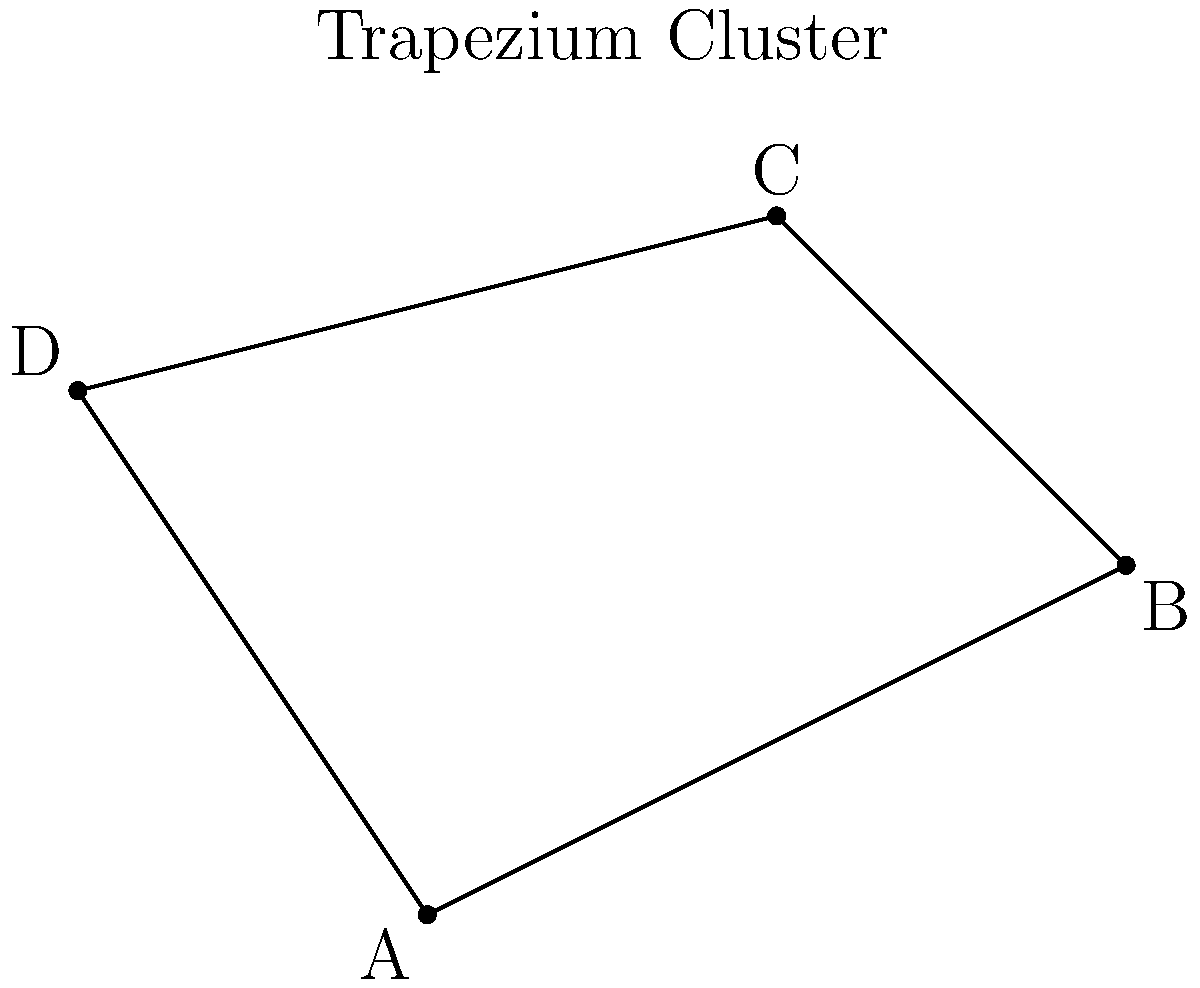During your astrophotography session in Lille, you capture an image of the Orion Nebula. Within this nebula, you notice the famous Trapezium Cluster. Which star in the diagram represents the brightest member of this cluster, often referred to as θ¹ Orionis C? To answer this question, let's consider the properties of the Trapezium Cluster and its brightest member:

1. The Trapezium Cluster is a group of young, hot stars at the heart of the Orion Nebula.

2. The cluster is named for its trapezoidal shape, formed by its four brightest stars.

3. The brightest star in the cluster is θ¹ Orionis C, which is also the most massive.

4. In most depictions and actual observations, θ¹ Orionis C appears at the top of the trapezoid.

5. Looking at our diagram, we can see a trapezoidal shape formed by the four points A, B, C, and D.

6. Point C is positioned at the top of the trapezoid, corresponding to the typical location of θ¹ Orionis C in real observations.

Therefore, in this representation, point C most likely represents θ¹ Orionis C, the brightest star in the Trapezium Cluster.
Answer: C 